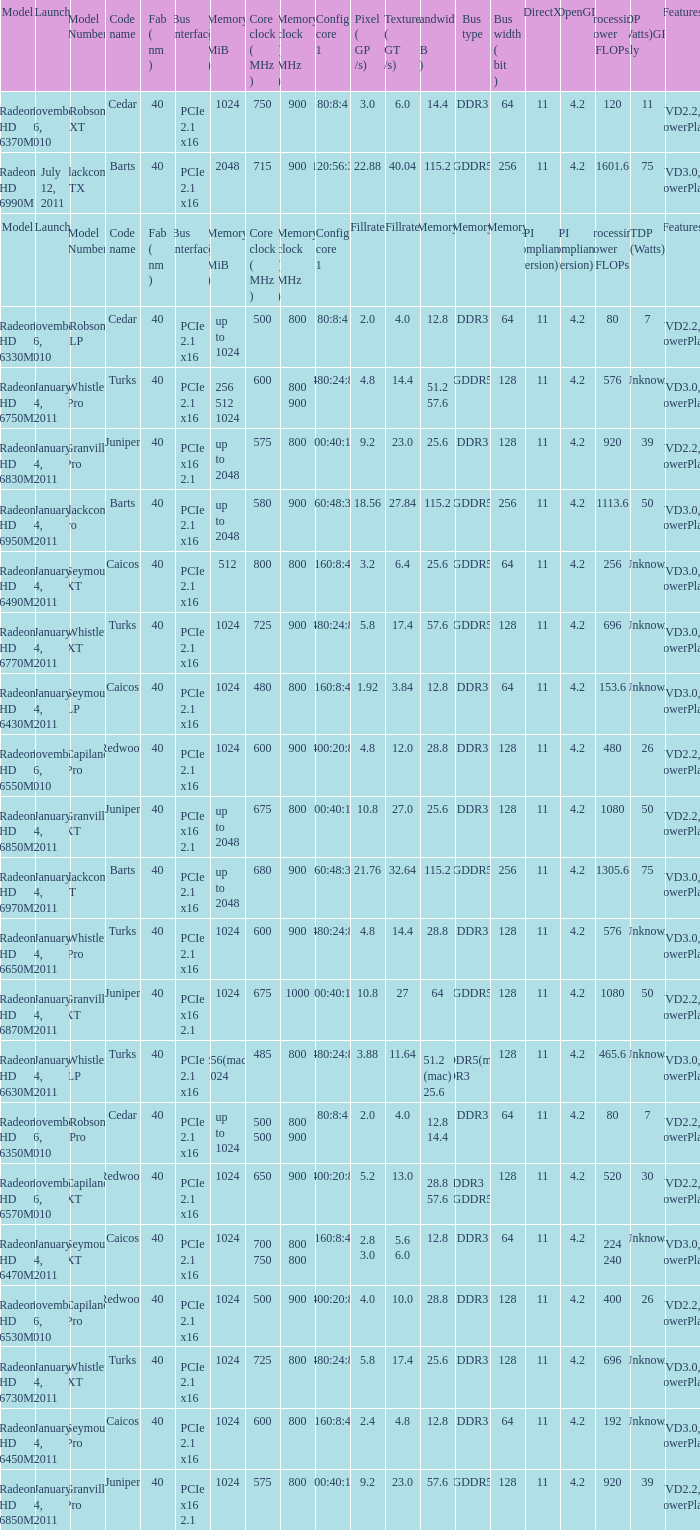How many values for bus width have a bandwidth of 25.6 and model number of Granville Pro? 1.0. 